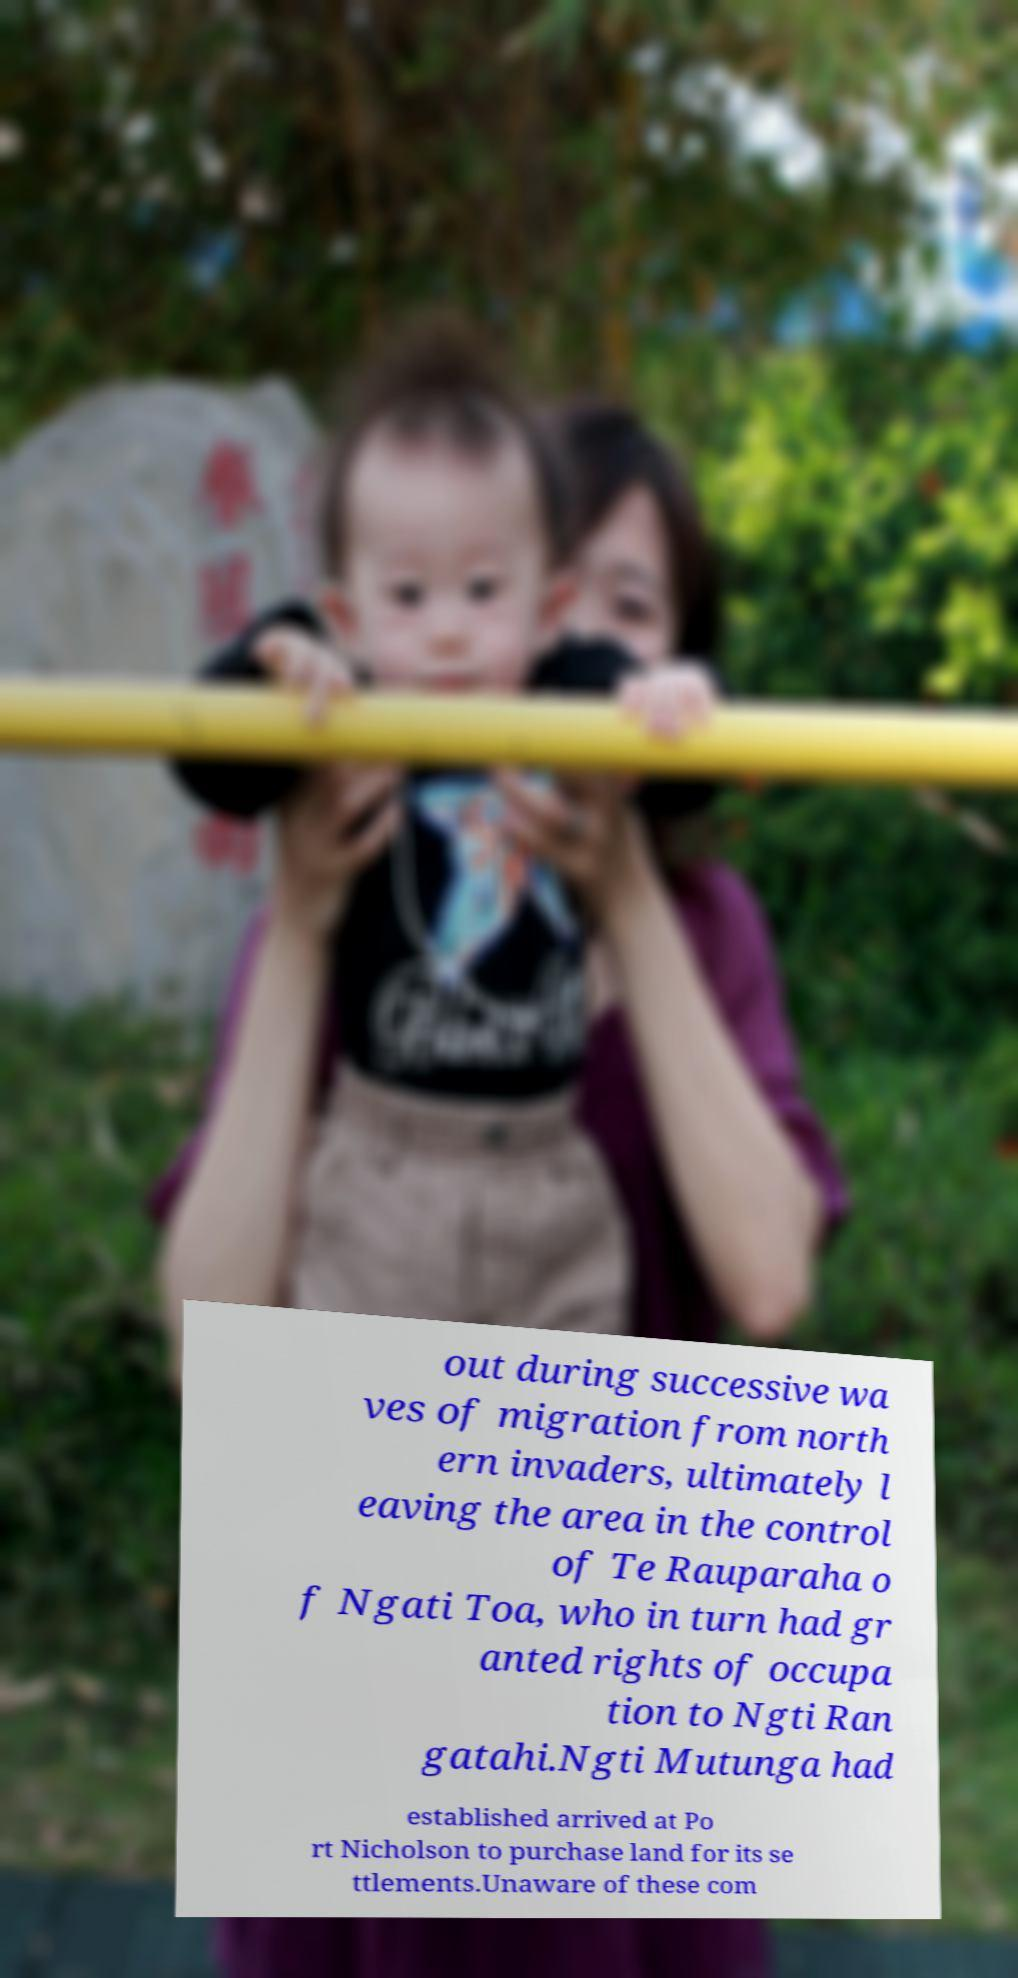Please identify and transcribe the text found in this image. out during successive wa ves of migration from north ern invaders, ultimately l eaving the area in the control of Te Rauparaha o f Ngati Toa, who in turn had gr anted rights of occupa tion to Ngti Ran gatahi.Ngti Mutunga had established arrived at Po rt Nicholson to purchase land for its se ttlements.Unaware of these com 